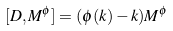<formula> <loc_0><loc_0><loc_500><loc_500>[ D , M ^ { \phi } ] = ( \phi ( k ) - k ) M ^ { \phi }</formula> 